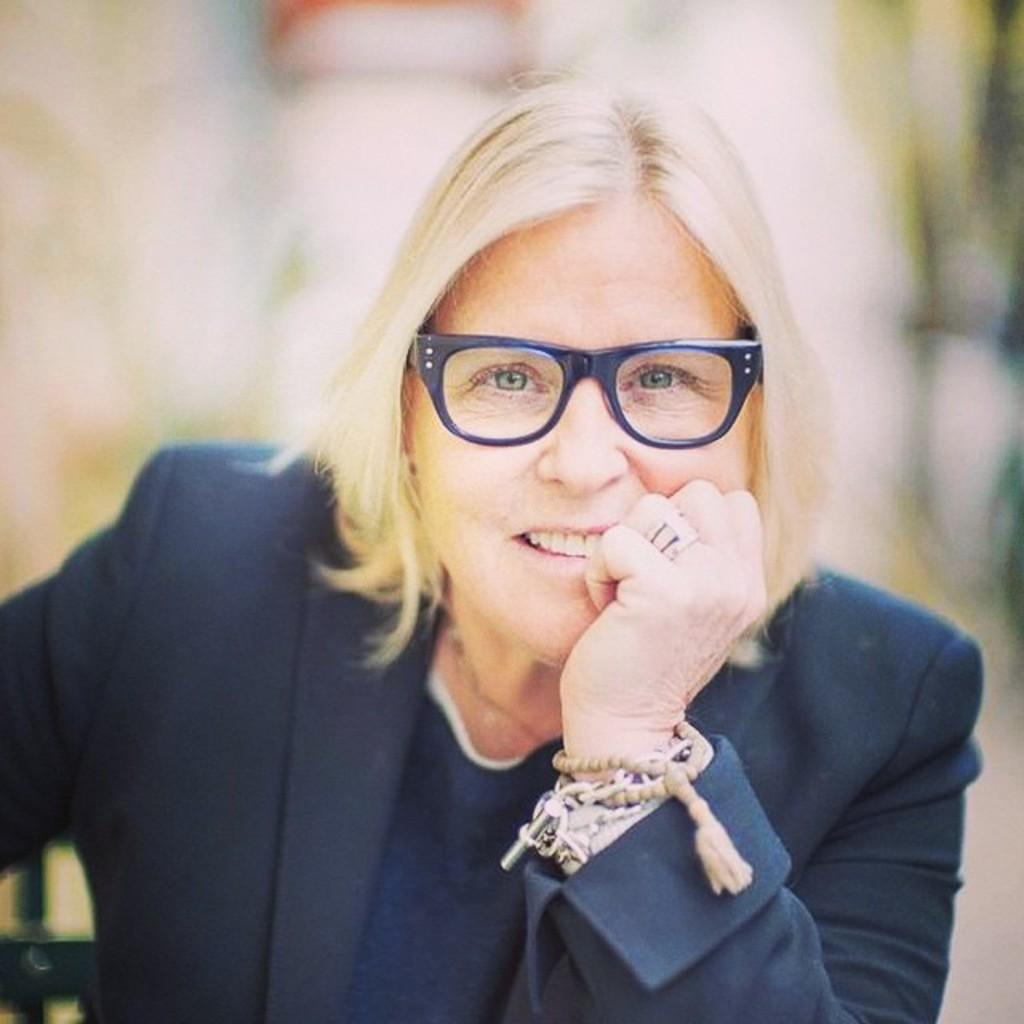Who is the main subject in the image? There is a woman in the image. What is the woman wearing? The woman is wearing a dark blue dress. Can you describe the background of the image? The background of the image is blurred. What type of thunder can be heard in the image? There is no sound present in the image, so it is not possible to determine if thunder can be heard. 